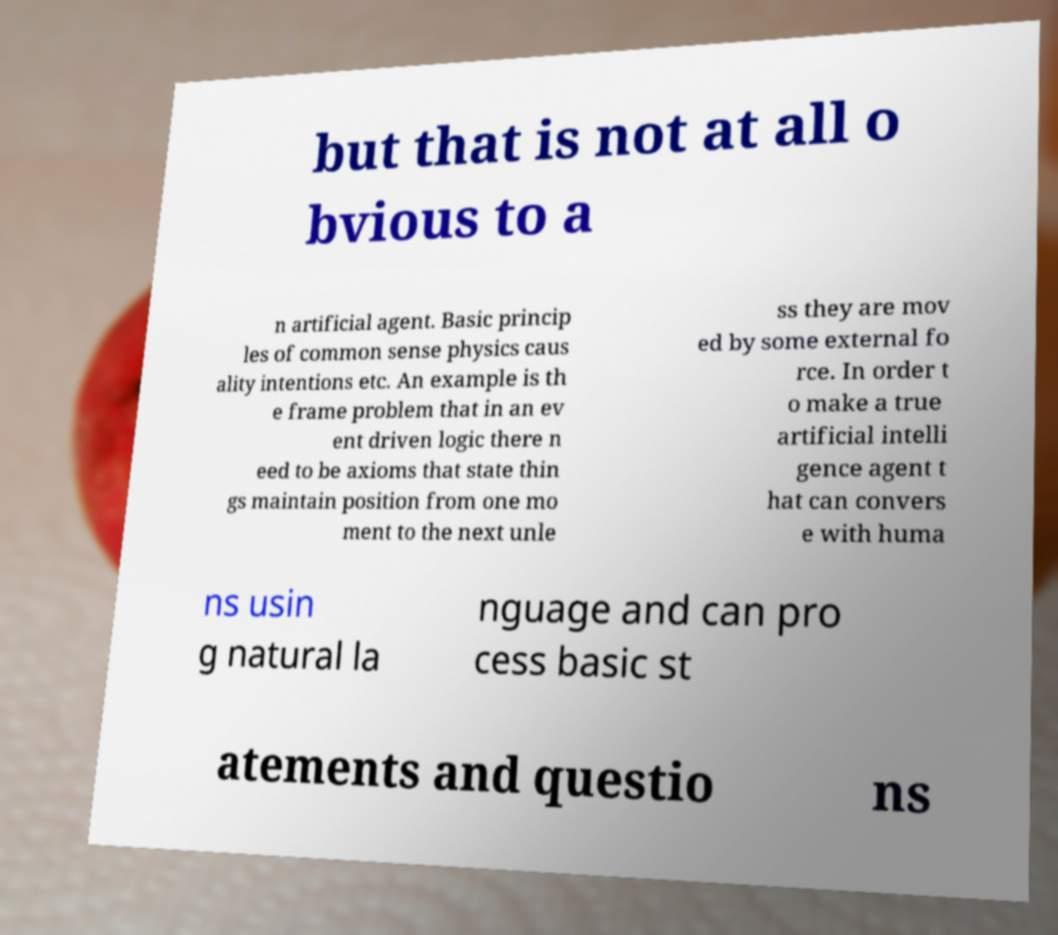Can you accurately transcribe the text from the provided image for me? but that is not at all o bvious to a n artificial agent. Basic princip les of common sense physics caus ality intentions etc. An example is th e frame problem that in an ev ent driven logic there n eed to be axioms that state thin gs maintain position from one mo ment to the next unle ss they are mov ed by some external fo rce. In order t o make a true artificial intelli gence agent t hat can convers e with huma ns usin g natural la nguage and can pro cess basic st atements and questio ns 